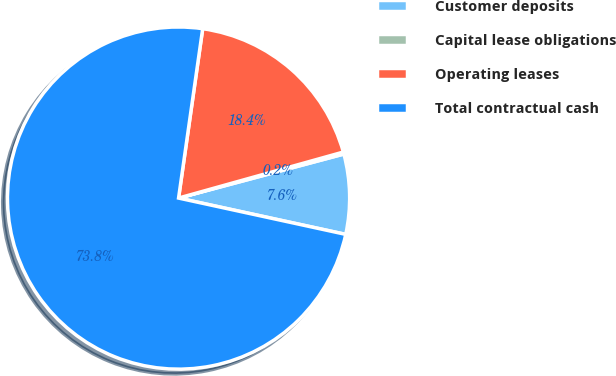<chart> <loc_0><loc_0><loc_500><loc_500><pie_chart><fcel>Customer deposits<fcel>Capital lease obligations<fcel>Operating leases<fcel>Total contractual cash<nl><fcel>7.55%<fcel>0.19%<fcel>18.41%<fcel>73.84%<nl></chart> 